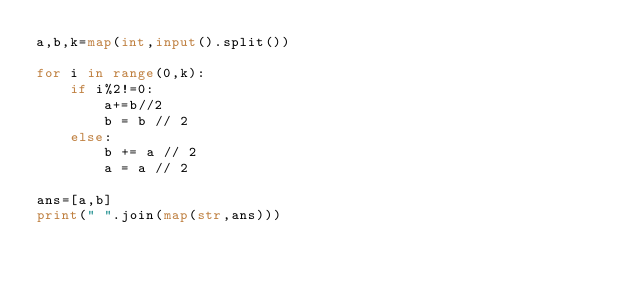<code> <loc_0><loc_0><loc_500><loc_500><_Python_>a,b,k=map(int,input().split())

for i in range(0,k):
    if i%2!=0:
        a+=b//2
        b = b // 2
    else:
        b += a // 2
        a = a // 2

ans=[a,b]
print(" ".join(map(str,ans)))</code> 